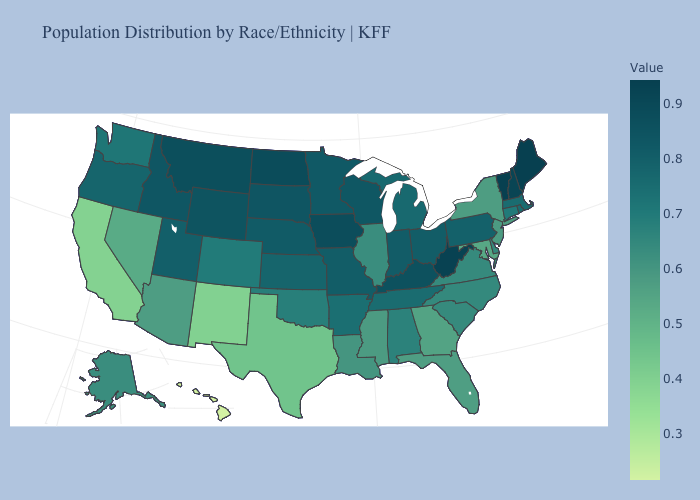Which states hav the highest value in the MidWest?
Quick response, please. North Dakota. Is the legend a continuous bar?
Short answer required. Yes. Which states have the highest value in the USA?
Give a very brief answer. Vermont. Does Michigan have a higher value than Maine?
Give a very brief answer. No. 